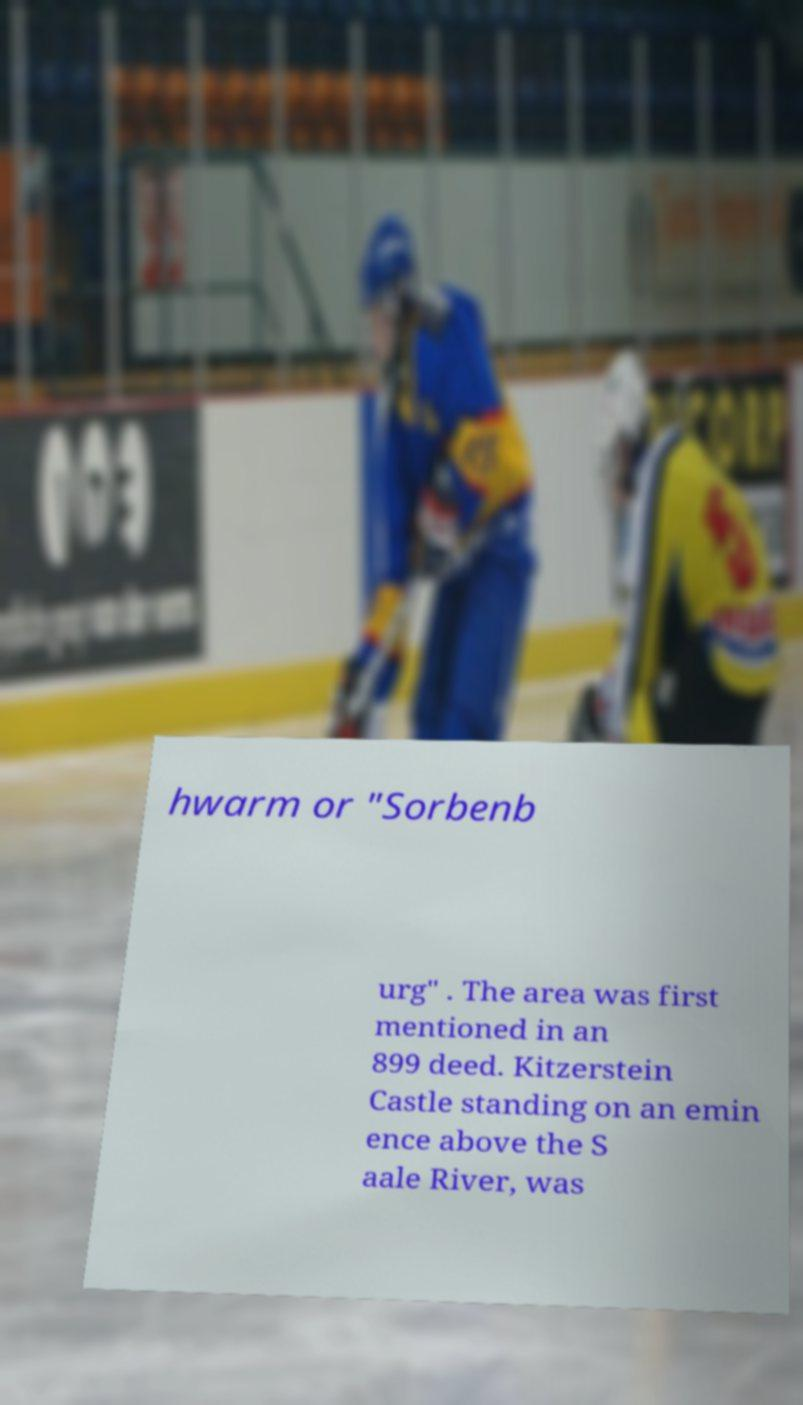Please read and relay the text visible in this image. What does it say? hwarm or "Sorbenb urg" . The area was first mentioned in an 899 deed. Kitzerstein Castle standing on an emin ence above the S aale River, was 